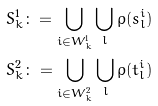Convert formula to latex. <formula><loc_0><loc_0><loc_500><loc_500>S _ { k } ^ { 1 } \colon = \bigcup _ { i \in W ^ { 1 } _ { k } } \bigcup _ { l } \rho ( s ^ { i } _ { l } ) \\ S _ { k } ^ { 2 } \colon = \bigcup _ { i \in W ^ { 2 } _ { k } } \bigcup _ { l } \rho ( t ^ { i } _ { l } )</formula> 